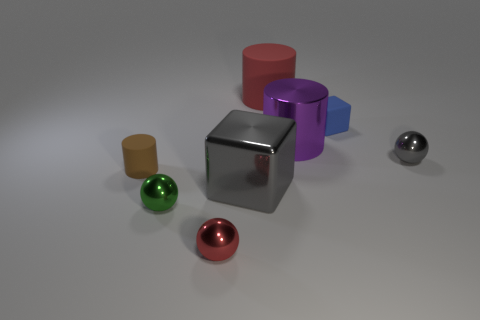Subtract all large purple metallic cylinders. How many cylinders are left? 2 Add 1 large purple objects. How many objects exist? 9 Subtract all green balls. How many balls are left? 2 Subtract 3 cylinders. How many cylinders are left? 0 Subtract all cylinders. How many objects are left? 5 Subtract all red balls. Subtract all green cubes. How many balls are left? 2 Subtract all small purple metal spheres. Subtract all blue rubber blocks. How many objects are left? 7 Add 8 green shiny objects. How many green shiny objects are left? 9 Add 3 large objects. How many large objects exist? 6 Subtract 1 brown cylinders. How many objects are left? 7 